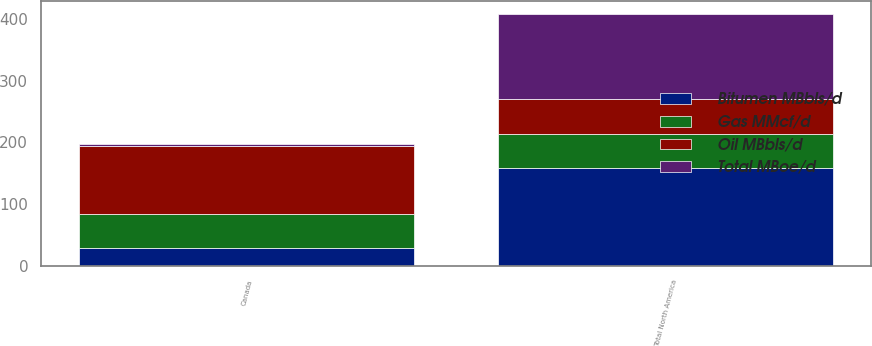<chart> <loc_0><loc_0><loc_500><loc_500><stacked_bar_chart><ecel><fcel>Canada<fcel>Total North America<nl><fcel>Bitumen MBbls/d<fcel>28<fcel>158<nl><fcel>Gas MMcf/d<fcel>56<fcel>56<nl><fcel>Oil MBbls/d<fcel>111<fcel>56<nl><fcel>Total MBoe/d<fcel>2<fcel>139<nl></chart> 